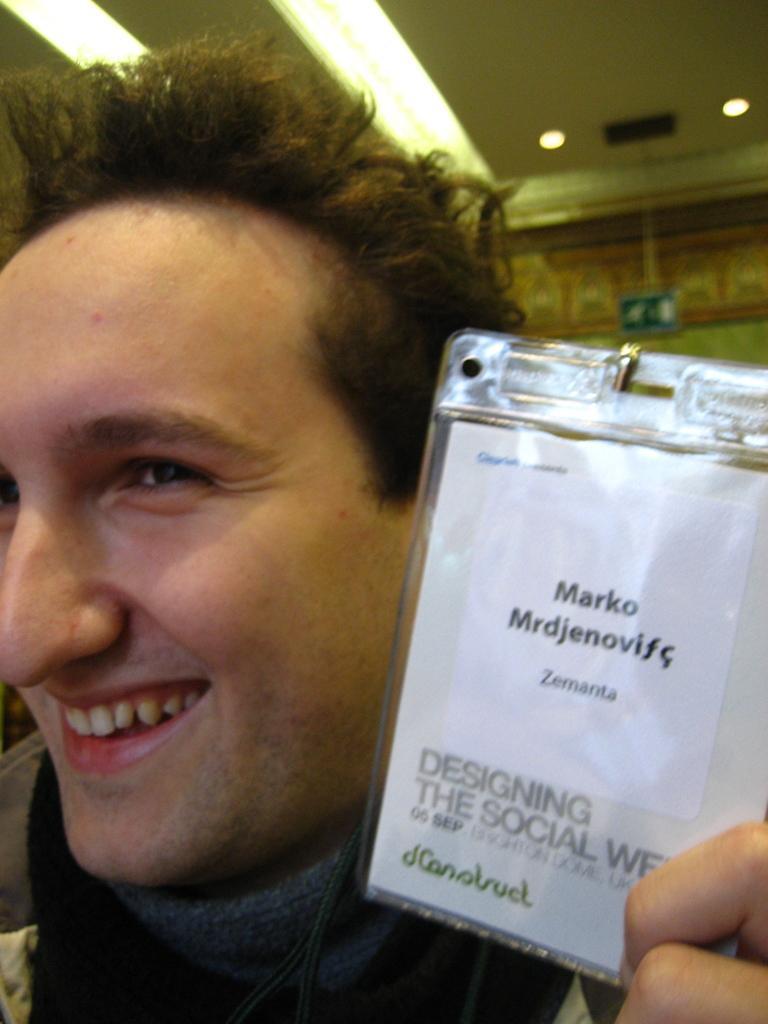Describe this image in one or two sentences. In this image, we can see a person holding an object with some text written. In the background, we can see the wall and a board. We can also see the roof with some lights. 